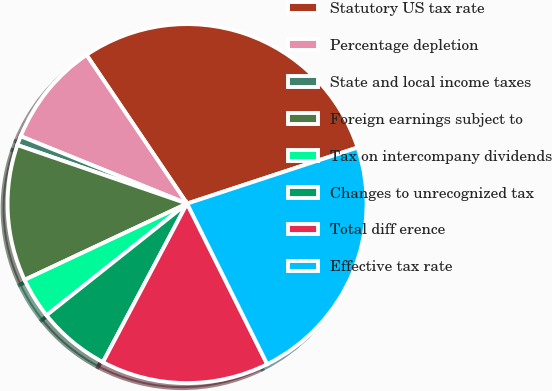Convert chart. <chart><loc_0><loc_0><loc_500><loc_500><pie_chart><fcel>Statutory US tax rate<fcel>Percentage depletion<fcel>State and local income taxes<fcel>Foreign earnings subject to<fcel>Tax on intercompany dividends<fcel>Changes to unrecognized tax<fcel>Total diff erence<fcel>Effective tax rate<nl><fcel>29.41%<fcel>9.41%<fcel>0.84%<fcel>12.27%<fcel>3.7%<fcel>6.55%<fcel>15.13%<fcel>22.69%<nl></chart> 